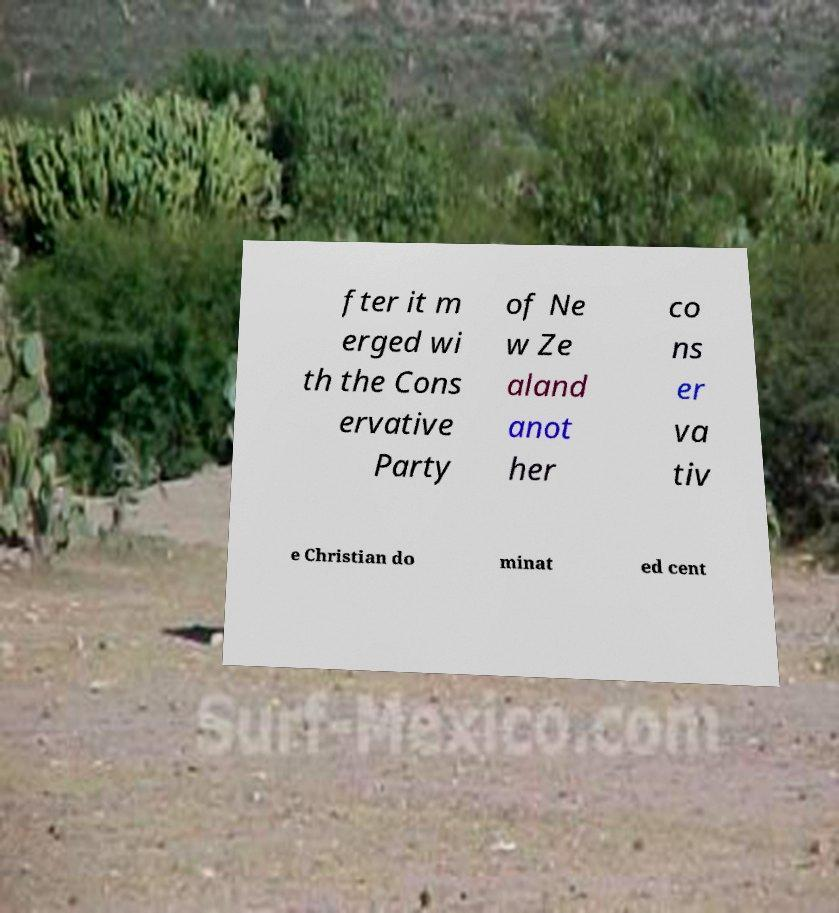Please read and relay the text visible in this image. What does it say? fter it m erged wi th the Cons ervative Party of Ne w Ze aland anot her co ns er va tiv e Christian do minat ed cent 